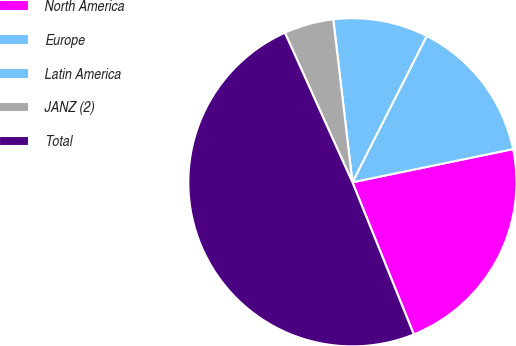Convert chart. <chart><loc_0><loc_0><loc_500><loc_500><pie_chart><fcel>North America<fcel>Europe<fcel>Latin America<fcel>JANZ (2)<fcel>Total<nl><fcel>22.14%<fcel>14.28%<fcel>9.34%<fcel>4.89%<fcel>49.36%<nl></chart> 